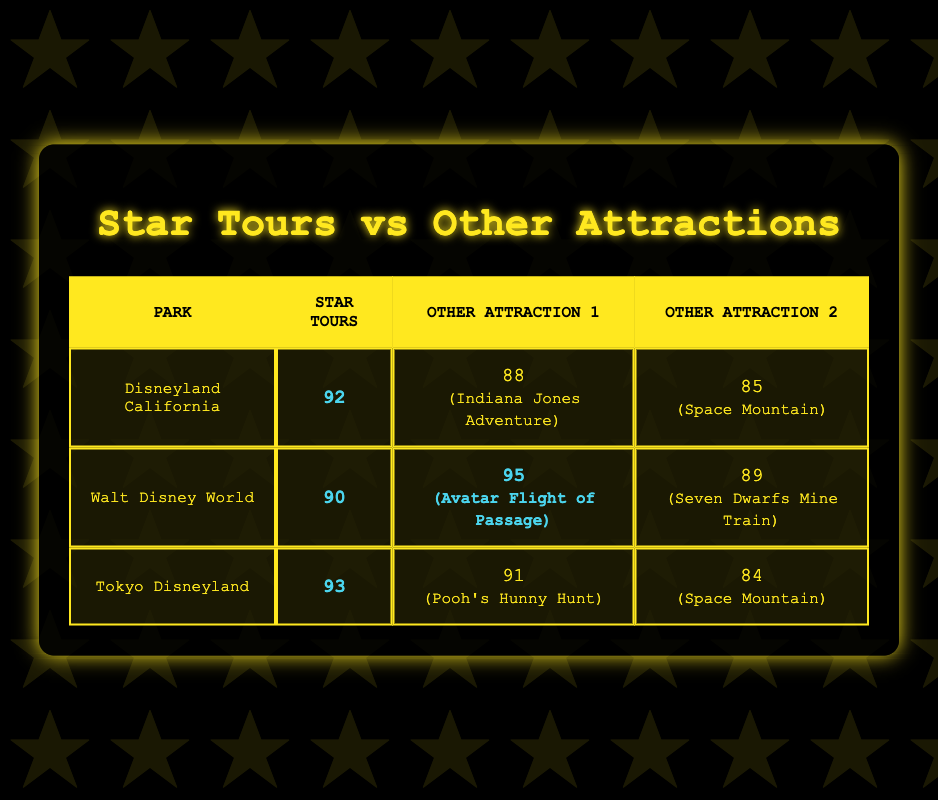What is the satisfaction rating for Star Tours at Disneyland California? The table shows that the satisfaction rating for Star Tours at Disneyland California is 92.
Answer: 92 Which attraction has the highest satisfaction rating at Walt Disney World? According to the table, Avatar Flight of Passage has the highest rating at 95 among the listed attractions at Walt Disney World.
Answer: 95 What is the difference in satisfaction ratings between Star Tours at Tokyo Disneyland and the other attractions there? At Tokyo Disneyland, Star Tours has a rating of 93, Pooh's Hunny Hunt has 91, and Space Mountain has 84. The difference between Star Tours and Pooh's Hunny Hunt is 2 (93 - 91), and the difference between Star Tours and Space Mountain is 9 (93 - 84). Thus, it performs better than both attractions by these amounts.
Answer: 2 and 9 True or False: The satisfaction rating for Star Tours is higher at Disneyland California than at Walt Disney World. The ratings show Star Tours is 92 at Disneyland California and 90 at Walt Disney World, confirming that Disneyland California's rating is higher.
Answer: True What is the average satisfaction rating for the attractions listed at Disneyland California? The attractions at Disneyland California are Star Tours (92), Indiana Jones Adventure (88), and Space Mountain (85). Summing these gives 92 + 88 + 85 = 265, and dividing by 3 gives an average of approximately 88.33.
Answer: 88.33 Which park had the lowest rating for an attraction and what was it? From the table, Space Mountain at Tokyo Disneyland has the lowest rating of 84 among the attractions listed.
Answer: 84 at Tokyo Disneyland Is the satisfaction rating for Star Tours higher than the rating for Indiana Jones Adventure? Star Tours has a rating of 92, and Indiana Jones Adventure has a rating of 88. Therefore, Star Tours is indeed rated higher.
Answer: Yes What is the highest satisfaction rating for any Star Wars-themed ride across all parks from the table? Reviewing the table, Star Tours has ratings of 92, 90, and 93 at Disneyland California, Walt Disney World, and Tokyo Disneyland respectively. So, the highest is 93 at Tokyo Disneyland.
Answer: 93 